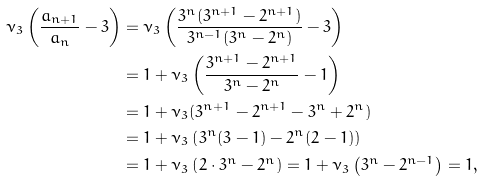<formula> <loc_0><loc_0><loc_500><loc_500>\nu _ { 3 } \left ( \frac { a _ { n + 1 } } { a _ { n } } - 3 \right ) & = \nu _ { 3 } \left ( \frac { 3 ^ { n } ( 3 ^ { n + 1 } - 2 ^ { n + 1 } ) } { 3 ^ { n - 1 } ( 3 ^ { n } - 2 ^ { n } ) } - 3 \right ) \\ & = 1 + \nu _ { 3 } \left ( \frac { 3 ^ { n + 1 } - 2 ^ { n + 1 } } { 3 ^ { n } - 2 ^ { n } } - 1 \right ) \\ & = 1 + \nu _ { 3 } ( 3 ^ { n + 1 } - 2 ^ { n + 1 } - 3 ^ { n } + 2 ^ { n } ) \\ & = 1 + \nu _ { 3 } \left ( 3 ^ { n } ( 3 - 1 ) - 2 ^ { n } ( 2 - 1 ) \right ) \\ & = 1 + \nu _ { 3 } \left ( 2 \cdot 3 ^ { n } - 2 ^ { n } \right ) = 1 + \nu _ { 3 } \left ( 3 ^ { n } - 2 ^ { n - 1 } \right ) = 1 ,</formula> 